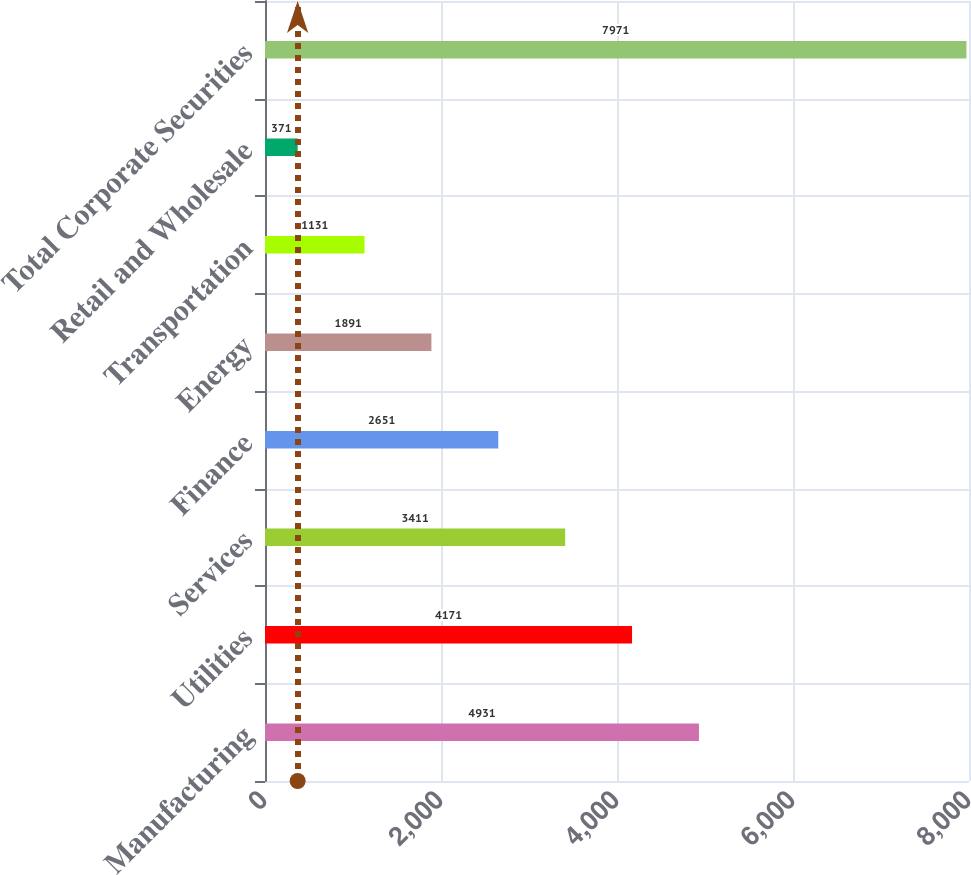Convert chart. <chart><loc_0><loc_0><loc_500><loc_500><bar_chart><fcel>Manufacturing<fcel>Utilities<fcel>Services<fcel>Finance<fcel>Energy<fcel>Transportation<fcel>Retail and Wholesale<fcel>Total Corporate Securities<nl><fcel>4931<fcel>4171<fcel>3411<fcel>2651<fcel>1891<fcel>1131<fcel>371<fcel>7971<nl></chart> 